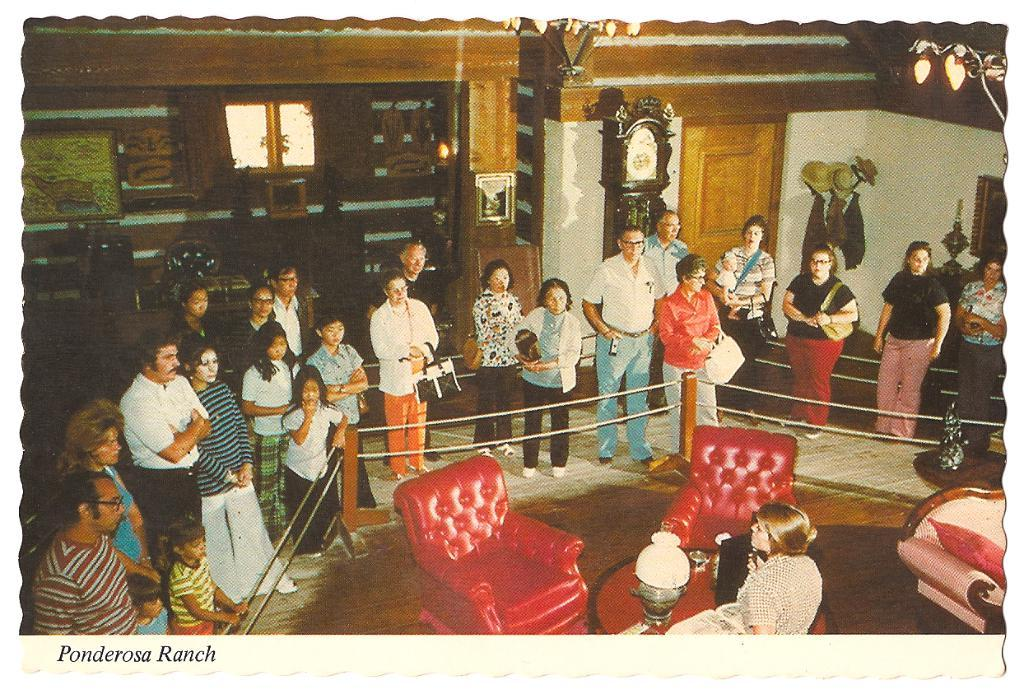<image>
Create a compact narrative representing the image presented. A picture of people standing around a chair titled Pandora Ranch. 